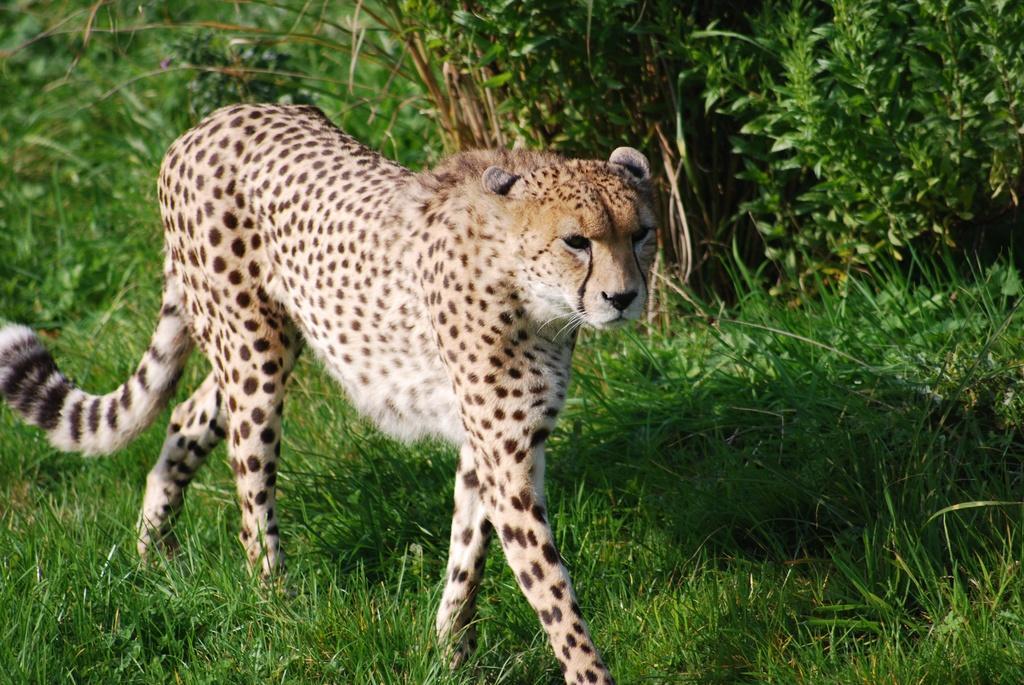In one or two sentences, can you explain what this image depicts? In this image there is a cheetah walking on the ground. There is grass on the ground. Behind the cheetah there are plants on the ground. 